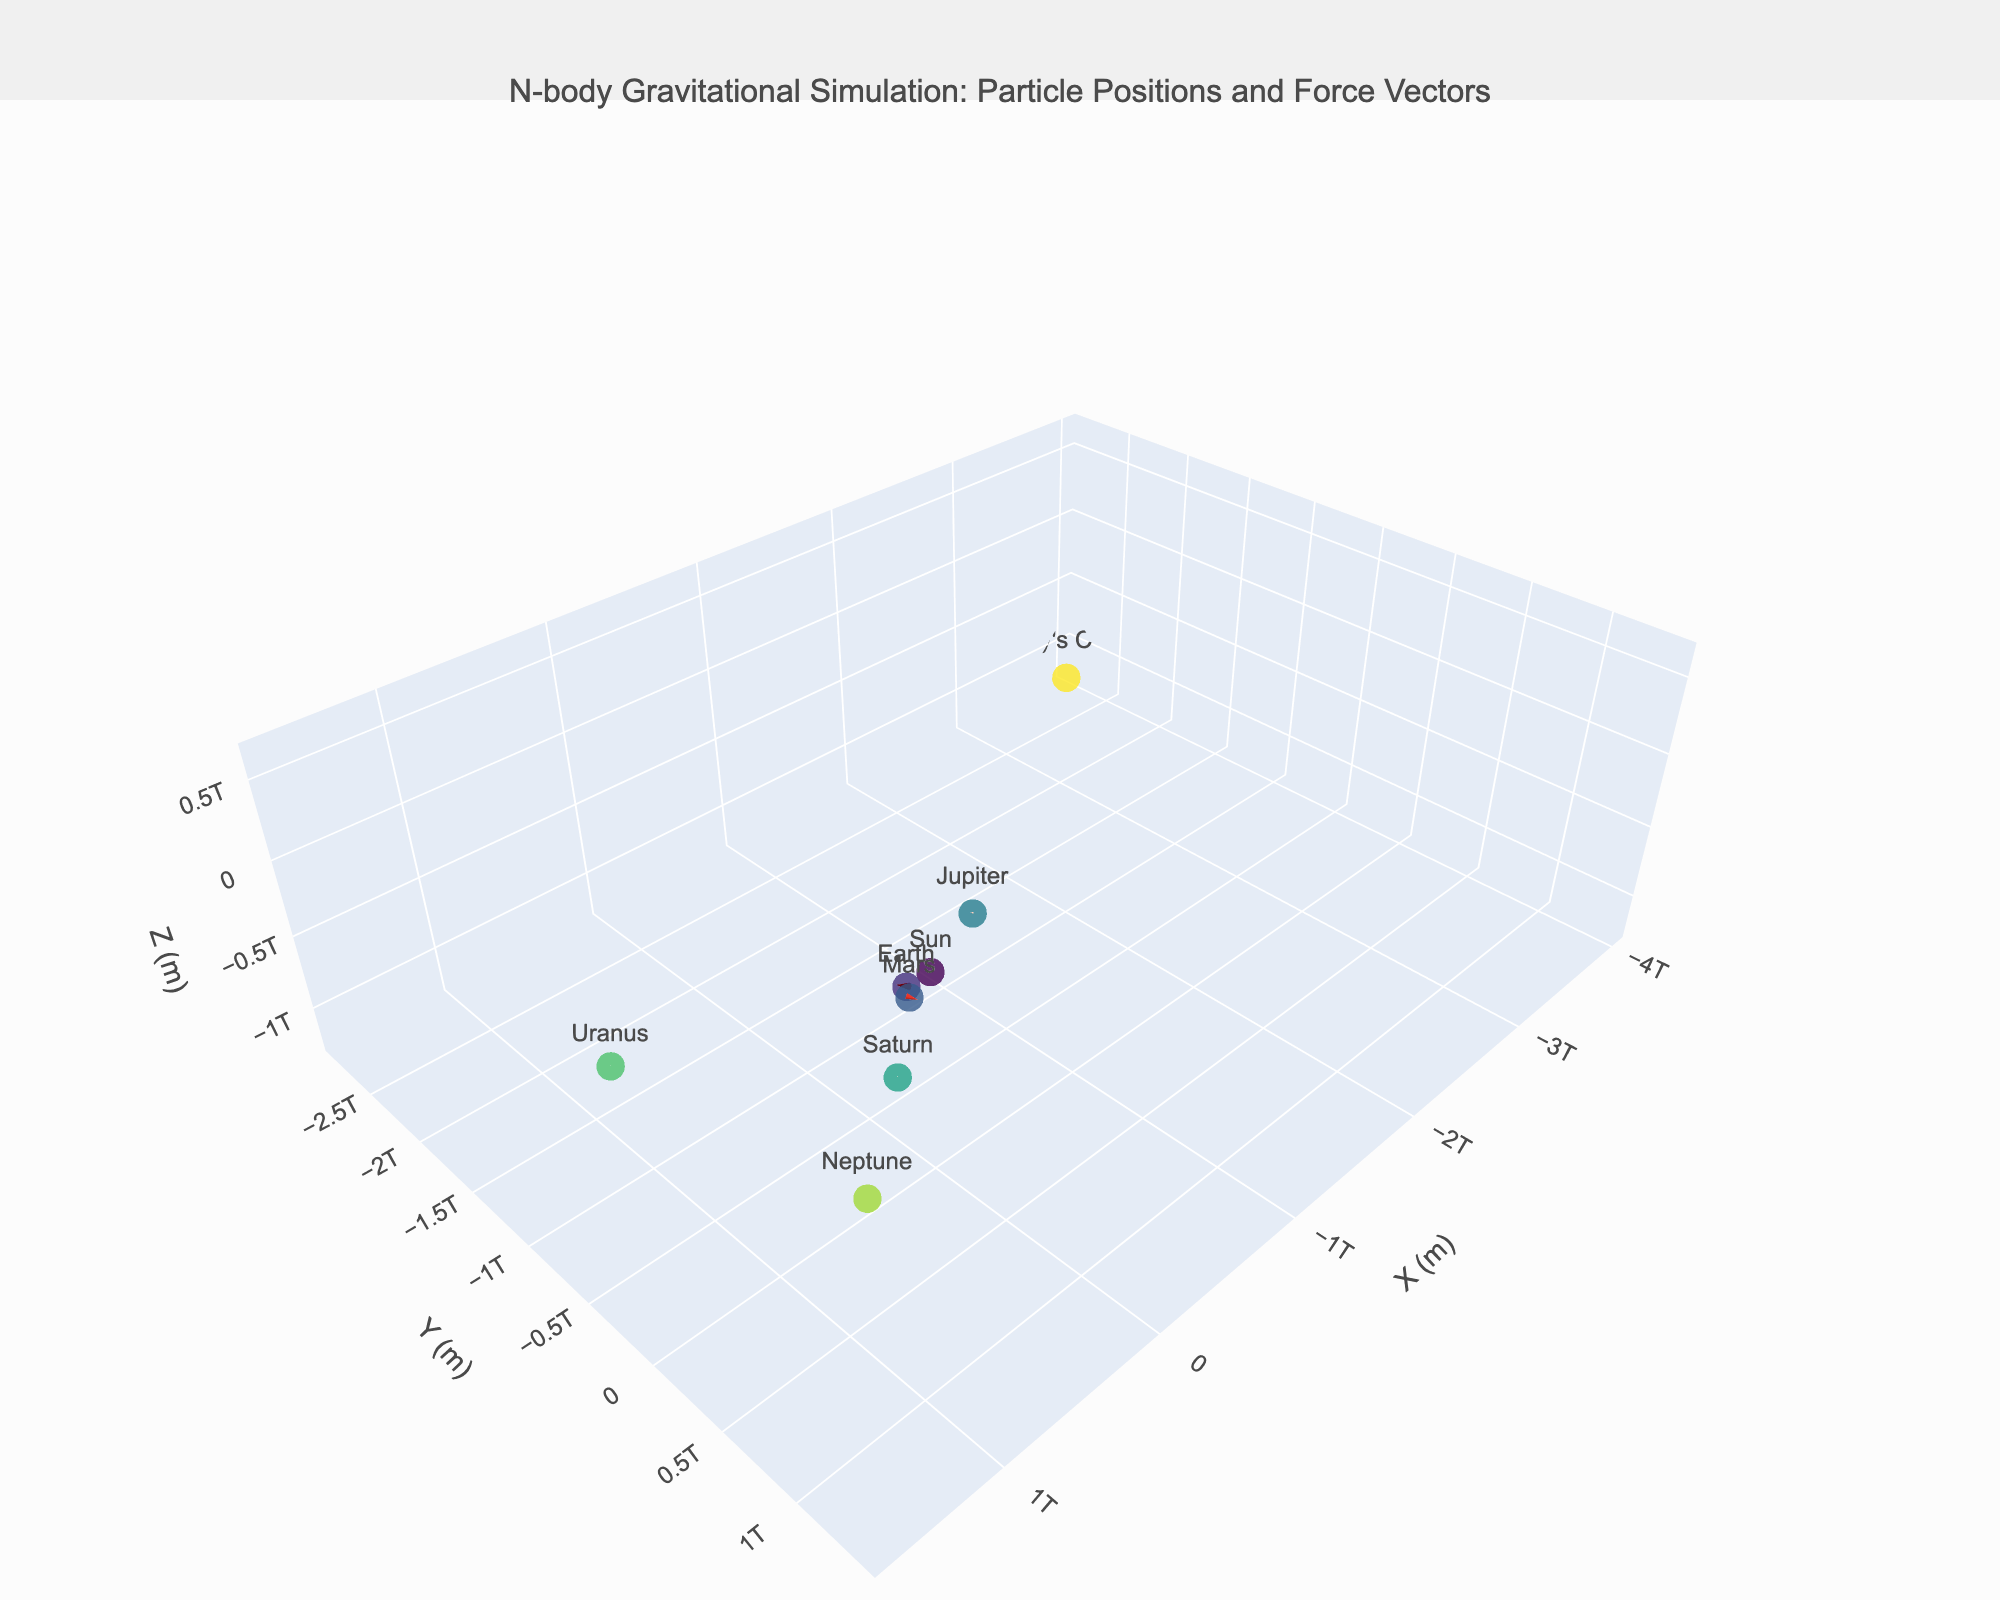what is the title of the plot? The title of the plot is displayed prominently at the top and provides a summary of the data shown in the figure: "N-body Gravitational Simulation: Particle Positions and Force Vectors".
Answer: N-body Gravitational Simulation: Particle Positions and Force Vectors How many particles are visualized in the plot? Counting the number of distinct marker points in the plot, each representing a particle, there are 8 visible particles in the figure.
Answer: 8 Which particle experiences the largest force in the positive X direction? By observing the length of the force vectors, which represent the force components (fx, fy, fz), Earth has the longest vector in the positive X direction, as indicated by its reported fx value of 3.6e-5.
Answer: Earth What are the X, Y, and Z coordinates of Mars? Mars' position is given by its coordinates: X is approximately 2.3e11 meters, Y is 1.1e11 meters, and Z is 5e10 meters. These values are shown in the hover text or can be inferred from the plot.
Answer: 2.3e11, 1.1e11, 5e10 What is the average Z position of all the particles? The Z positions of particles are: 0, 0, 5e10, -1.5e11, 2.8e11, -4e11, 6e11, -1.2e12. Summing these values: 0 + 0 + 5e10 - 1.5e11 + 2.8e11 - 4e11 + 6e11 - 1.2e12 = -7.4e11. The average is then -7.4e11 / 8.
Answer: -9.25e10 How does the force vector acting on Neptune compare to that on Mars? Observe the relative lengths and directions of the force vectors (cones) attached to Neptune and Mars. Mars' force vector is longer and pointing more towards positive Y and Z directions, while Neptune's is shorter and pointing in a similar, but less significant direction. Quantitatively, Mars has components (-1.8e-5, 2.7e-5, -9e-6), whereas Neptune has (-1e-6, 8e-7, -3e-7).
Answer: Mars has larger forces in all components compared to Neptune Which particle has the smallest force magnitude? The magnitude of the force vector can be calculated as sqrt(fx^2 + fy^2 + fz^2) for each particle. The particle with the smallest calculated magnitude corresponds to the smallest vector observed in the plot, which is for Halley's Comet.
Answer: Halley's Comet What direction is the force acting on Saturn? The direction of the force vector acting on Saturn can be inferred from its components. It has fx = -4e-6, fy = 3e-6, and fz = -1.5e-6, indicating the force is directed mostly towards the negative X, positive Y, and negative Z directions.
Answer: Negative X, Positive Y, Negative Z 